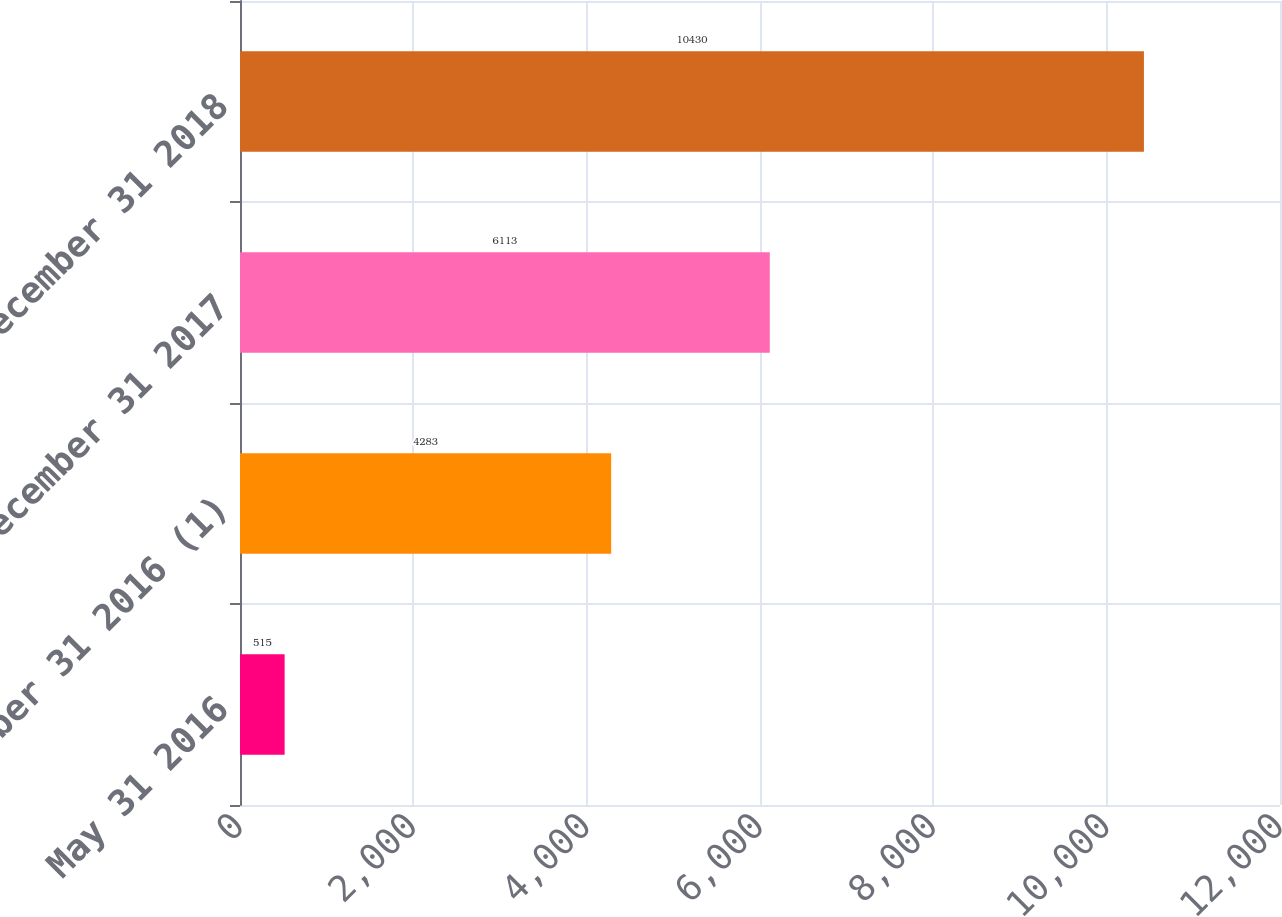<chart> <loc_0><loc_0><loc_500><loc_500><bar_chart><fcel>May 31 2016<fcel>December 31 2016 (1)<fcel>December 31 2017<fcel>December 31 2018<nl><fcel>515<fcel>4283<fcel>6113<fcel>10430<nl></chart> 